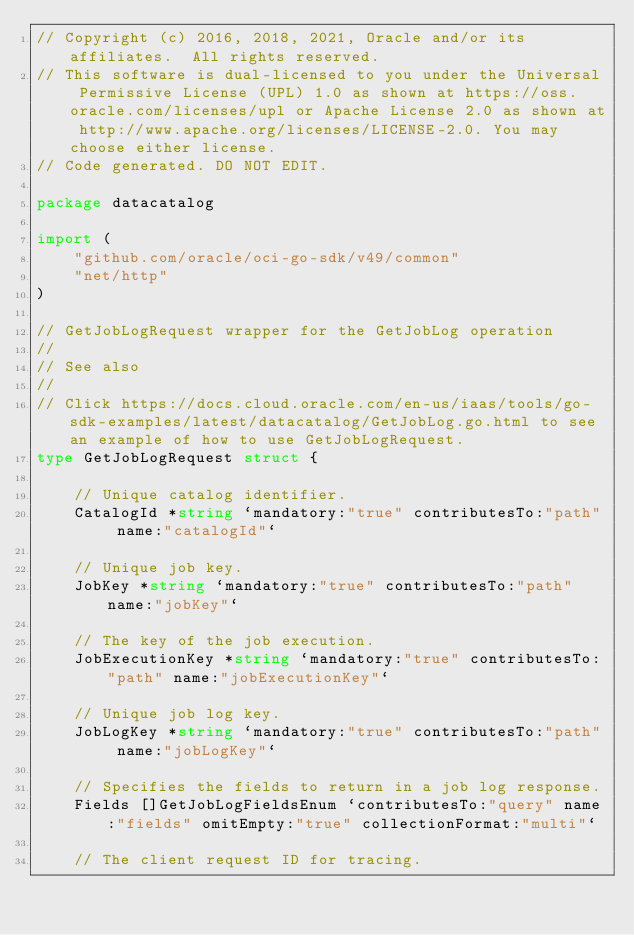<code> <loc_0><loc_0><loc_500><loc_500><_Go_>// Copyright (c) 2016, 2018, 2021, Oracle and/or its affiliates.  All rights reserved.
// This software is dual-licensed to you under the Universal Permissive License (UPL) 1.0 as shown at https://oss.oracle.com/licenses/upl or Apache License 2.0 as shown at http://www.apache.org/licenses/LICENSE-2.0. You may choose either license.
// Code generated. DO NOT EDIT.

package datacatalog

import (
	"github.com/oracle/oci-go-sdk/v49/common"
	"net/http"
)

// GetJobLogRequest wrapper for the GetJobLog operation
//
// See also
//
// Click https://docs.cloud.oracle.com/en-us/iaas/tools/go-sdk-examples/latest/datacatalog/GetJobLog.go.html to see an example of how to use GetJobLogRequest.
type GetJobLogRequest struct {

	// Unique catalog identifier.
	CatalogId *string `mandatory:"true" contributesTo:"path" name:"catalogId"`

	// Unique job key.
	JobKey *string `mandatory:"true" contributesTo:"path" name:"jobKey"`

	// The key of the job execution.
	JobExecutionKey *string `mandatory:"true" contributesTo:"path" name:"jobExecutionKey"`

	// Unique job log key.
	JobLogKey *string `mandatory:"true" contributesTo:"path" name:"jobLogKey"`

	// Specifies the fields to return in a job log response.
	Fields []GetJobLogFieldsEnum `contributesTo:"query" name:"fields" omitEmpty:"true" collectionFormat:"multi"`

	// The client request ID for tracing.</code> 